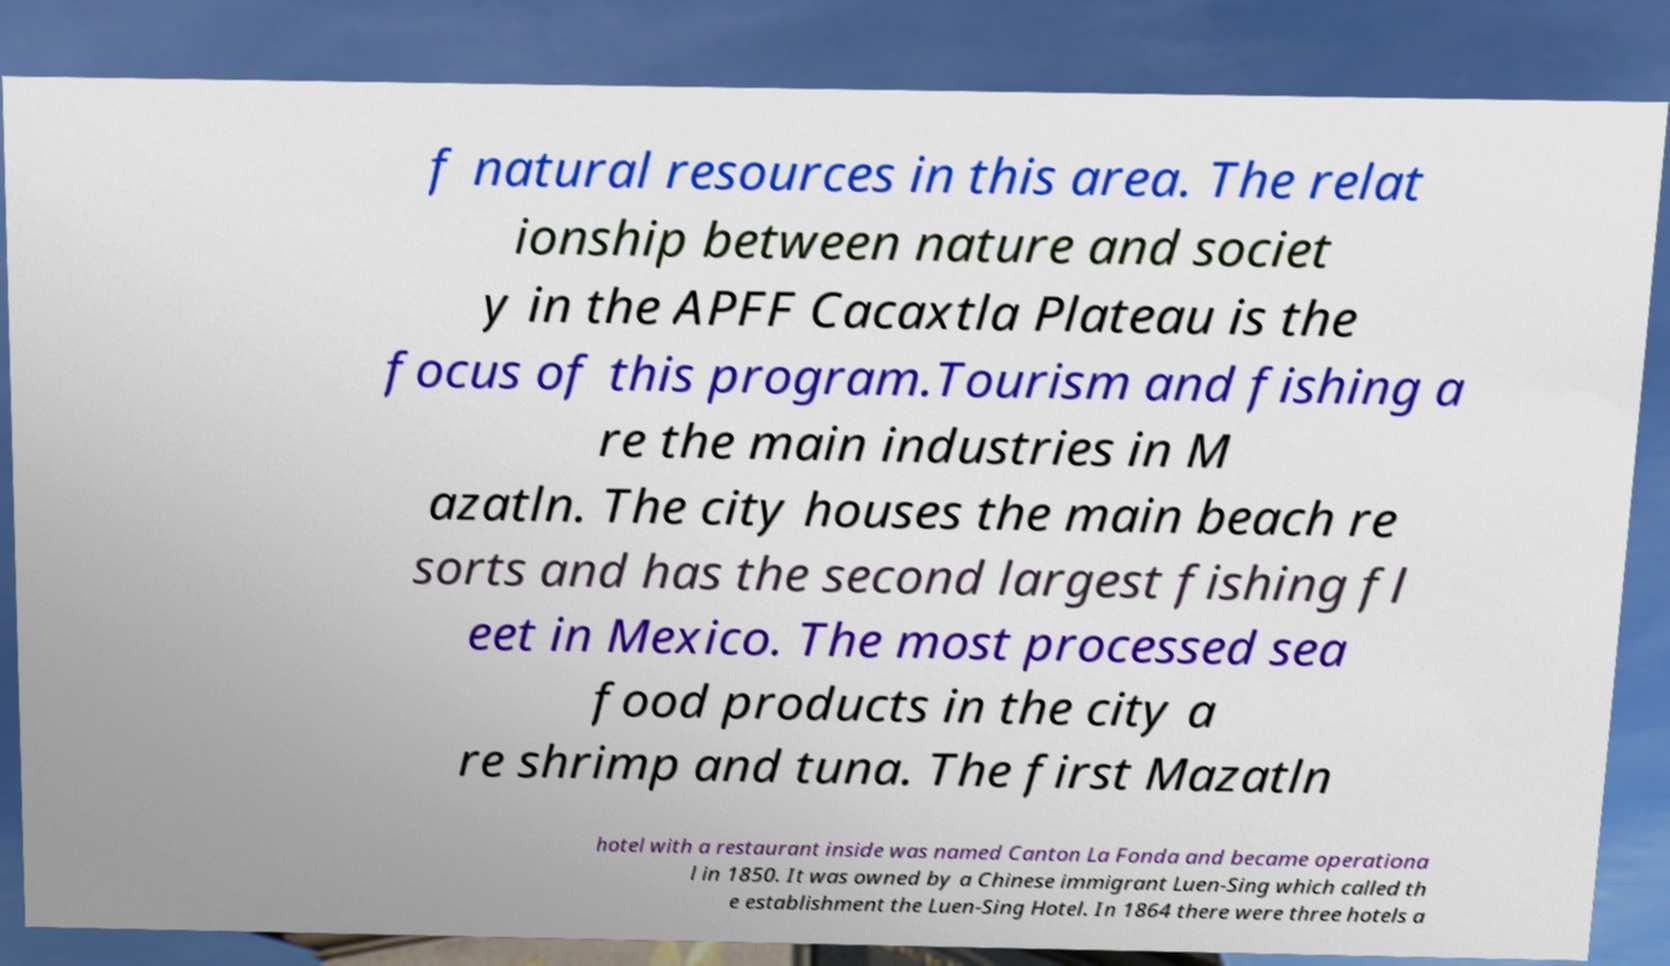Could you assist in decoding the text presented in this image and type it out clearly? f natural resources in this area. The relat ionship between nature and societ y in the APFF Cacaxtla Plateau is the focus of this program.Tourism and fishing a re the main industries in M azatln. The city houses the main beach re sorts and has the second largest fishing fl eet in Mexico. The most processed sea food products in the city a re shrimp and tuna. The first Mazatln hotel with a restaurant inside was named Canton La Fonda and became operationa l in 1850. It was owned by a Chinese immigrant Luen-Sing which called th e establishment the Luen-Sing Hotel. In 1864 there were three hotels a 